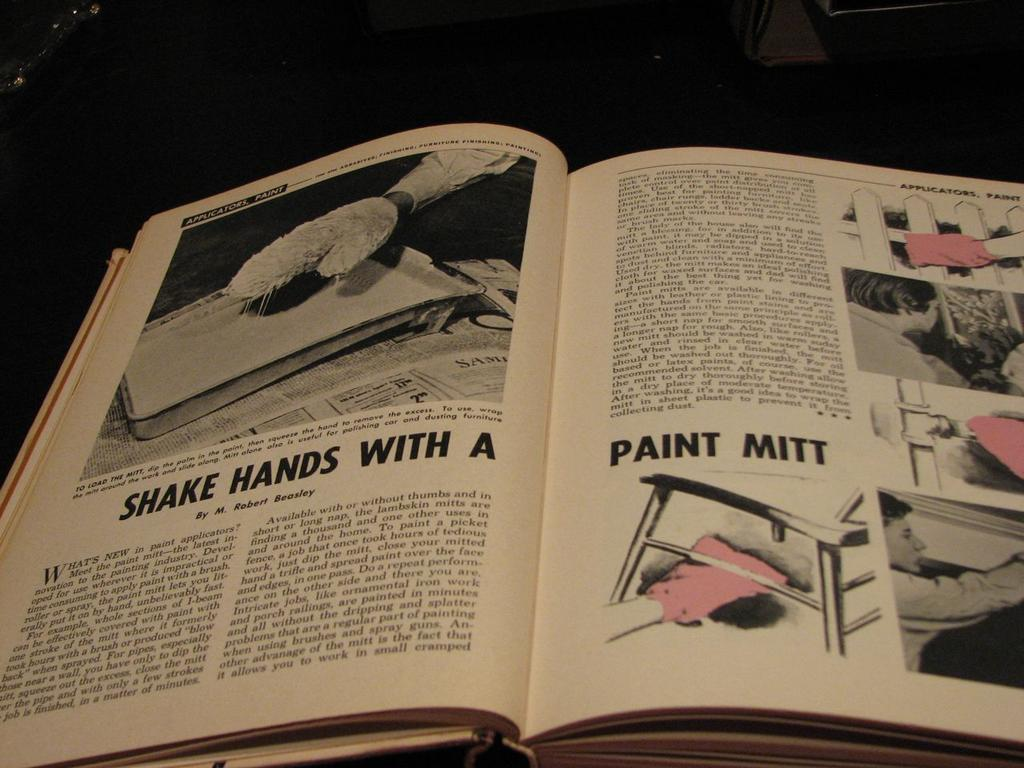<image>
Share a concise interpretation of the image provided. A book is open to a page with pink Paint Mitts. 